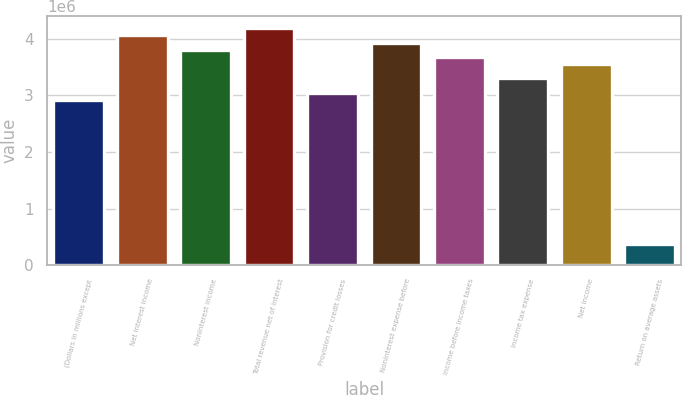Convert chart. <chart><loc_0><loc_0><loc_500><loc_500><bar_chart><fcel>(Dollars in millions except<fcel>Net interest income<fcel>Noninterest income<fcel>Total revenue net of interest<fcel>Provision for credit losses<fcel>Noninterest expense before<fcel>Income before income taxes<fcel>Income tax expense<fcel>Net income<fcel>Return on average assets<nl><fcel>2.92075e+06<fcel>4.06365e+06<fcel>3.80968e+06<fcel>4.19064e+06<fcel>3.04774e+06<fcel>3.93666e+06<fcel>3.68269e+06<fcel>3.30172e+06<fcel>3.5557e+06<fcel>380968<nl></chart> 